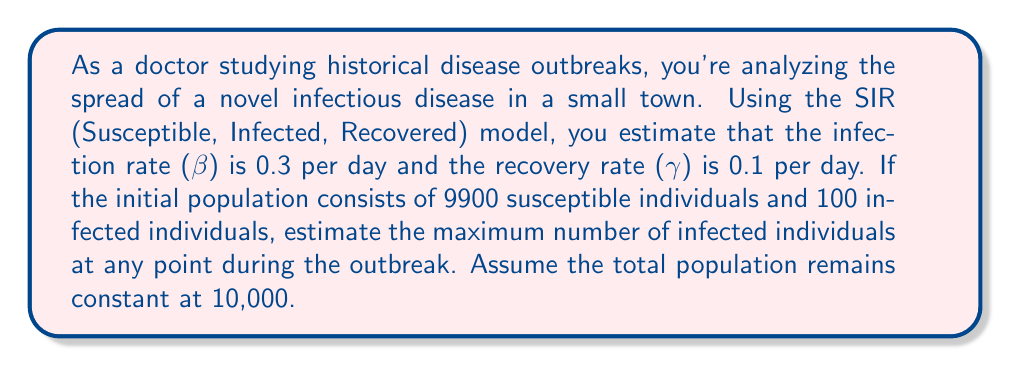Help me with this question. To solve this problem, we'll use the SIR model and some key concepts from epidemiology:

1) First, we need to calculate the basic reproduction number (R₀):
   $$R_0 = \frac{\beta}{\gamma} = \frac{0.3}{0.1} = 3$$

2) In the SIR model, the maximum number of infected individuals occurs when the rate of new infections equals the rate of recoveries. This happens when:
   $$S = \frac{N}{R_0} = \frac{10000}{3} \approx 3333.33$$

3) Let $I_{max}$ be the maximum number of infected individuals. We can use the fact that the total population remains constant:
   $$N = S + I + R$$

4) At the peak of infection, we can assume R ≈ 0 (since recoveries are just starting). So:
   $$10000 = 3333.33 + I_{max} + 0$$

5) Solving for $I_{max}$:
   $$I_{max} = 10000 - 3333.33 = 6666.67$$

6) However, we need to account for the initial conditions. The number of people who will eventually be infected is:
   $$N - S_{final} = N(1 - \frac{1}{R_0}) = 10000(1 - \frac{1}{3}) = 6666.67$$

7) Since we start with 100 infected individuals, the additional number who will be infected is:
   $$6666.67 - 100 = 6566.67$$

8) Therefore, the maximum number of infected individuals at any point will be:
   $$I_{max} = 6566.67$$

9) Rounding to the nearest whole number (as we can't have a fractional number of people):
   $$I_{max} = 6567$$
Answer: The maximum number of infected individuals at any point during the outbreak is estimated to be 6,567 people. 